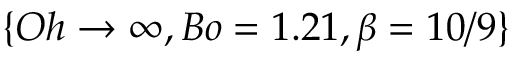Convert formula to latex. <formula><loc_0><loc_0><loc_500><loc_500>\{ O h \rightarrow \infty , B o = 1 . 2 1 , \beta = 1 0 / 9 \}</formula> 